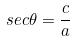Convert formula to latex. <formula><loc_0><loc_0><loc_500><loc_500>s e c \theta = \frac { c } { a }</formula> 